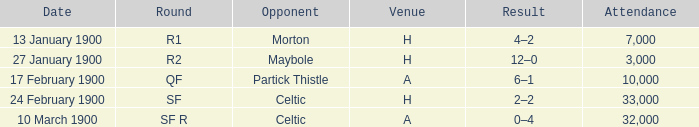What was the number of attendees at the game versus morton? 7000.0. Could you help me parse every detail presented in this table? {'header': ['Date', 'Round', 'Opponent', 'Venue', 'Result', 'Attendance'], 'rows': [['13 January 1900', 'R1', 'Morton', 'H', '4–2', '7,000'], ['27 January 1900', 'R2', 'Maybole', 'H', '12–0', '3,000'], ['17 February 1900', 'QF', 'Partick Thistle', 'A', '6–1', '10,000'], ['24 February 1900', 'SF', 'Celtic', 'H', '2–2', '33,000'], ['10 March 1900', 'SF R', 'Celtic', 'A', '0–4', '32,000']]} 